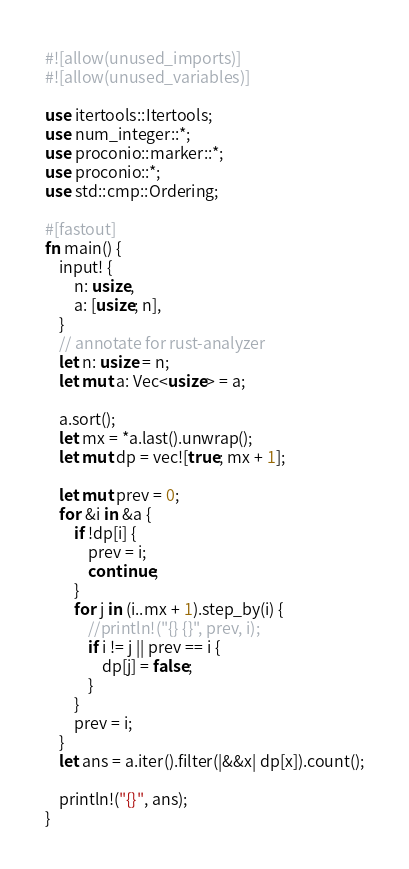<code> <loc_0><loc_0><loc_500><loc_500><_Rust_>#![allow(unused_imports)]
#![allow(unused_variables)]

use itertools::Itertools;
use num_integer::*;
use proconio::marker::*;
use proconio::*;
use std::cmp::Ordering;

#[fastout]
fn main() {
    input! {
        n: usize,
        a: [usize; n],
    }
    // annotate for rust-analyzer
    let n: usize = n;
    let mut a: Vec<usize> = a;

    a.sort();
    let mx = *a.last().unwrap();
    let mut dp = vec![true; mx + 1];

    let mut prev = 0;
    for &i in &a {
        if !dp[i] {
            prev = i;
            continue;
        }
        for j in (i..mx + 1).step_by(i) {
            //println!("{} {}", prev, i);
            if i != j || prev == i {
                dp[j] = false;
            }
        }
        prev = i;
    }
    let ans = a.iter().filter(|&&x| dp[x]).count();

    println!("{}", ans);
}
</code> 